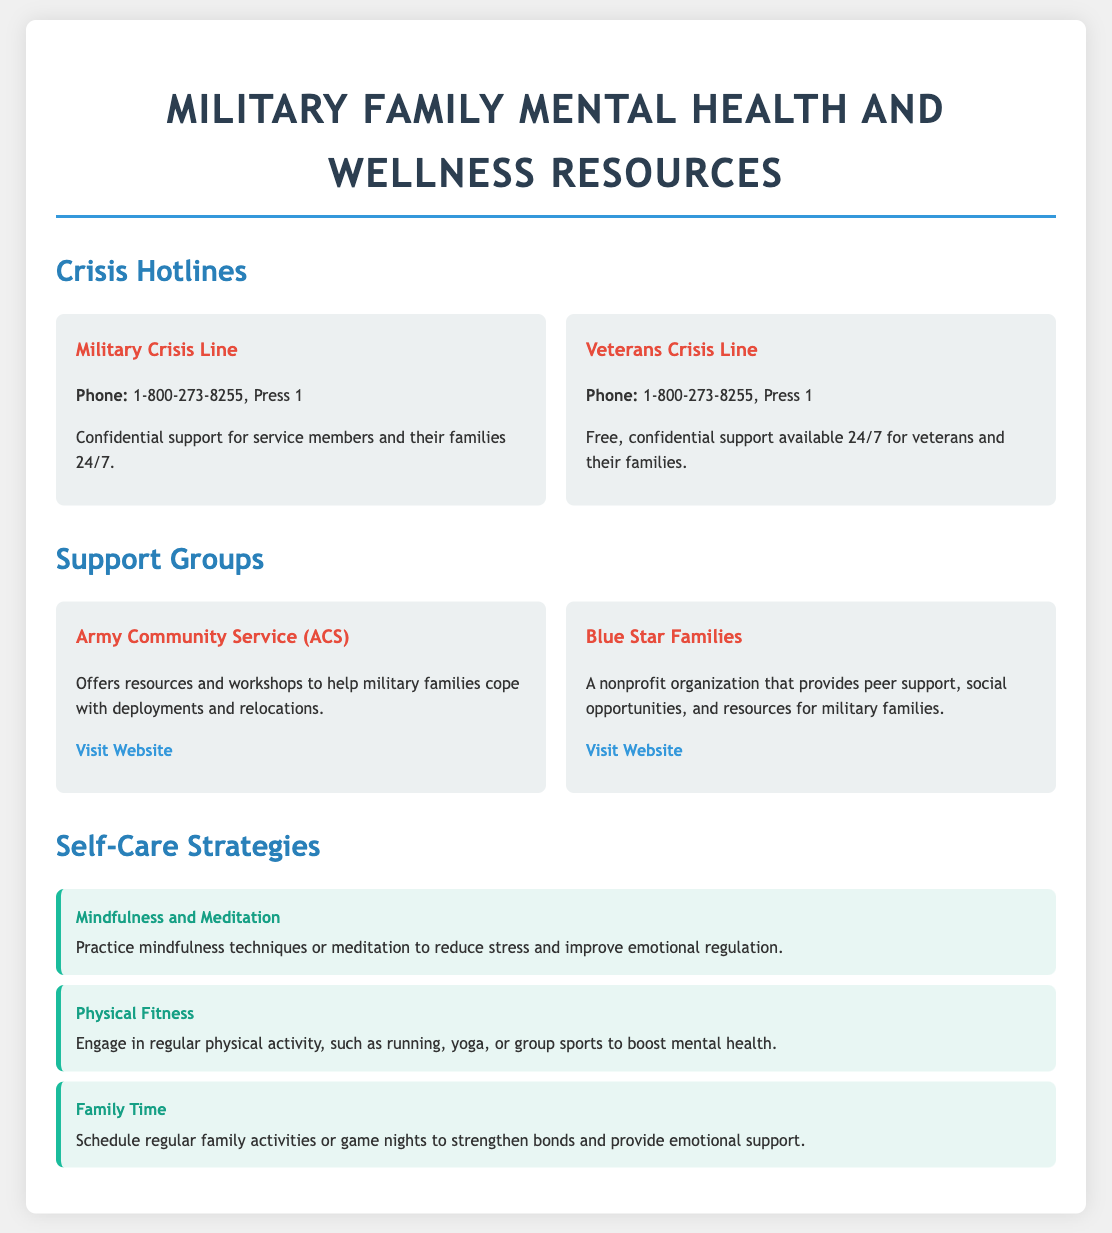What is the phone number for the Military Crisis Line? The phone number for the Military Crisis Line is provided in the document as 1-800-273-8255, Press 1.
Answer: 1-800-273-8255, Press 1 How many crisis hotlines are listed in the document? The document lists two crisis hotlines: the Military Crisis Line and the Veterans Crisis Line.
Answer: 2 What organization offers resources and workshops to help military families? The Army Community Service (ACS) is mentioned as offering resources and workshops to assist military families.
Answer: Army Community Service (ACS) Which self-care strategy focuses on emotional regulation? Mindfulness and Meditation is the self-care strategy aimed at improving emotional regulation.
Answer: Mindfulness and Meditation What is the website for Blue Star Families? The document provides a link to the Blue Star Families website for further resources and information.
Answer: https://bluestarfam.org How often should family activities be scheduled according to the document? The document suggests scheduling regular family activities or game nights to strengthen bonds.
Answer: Regularly 